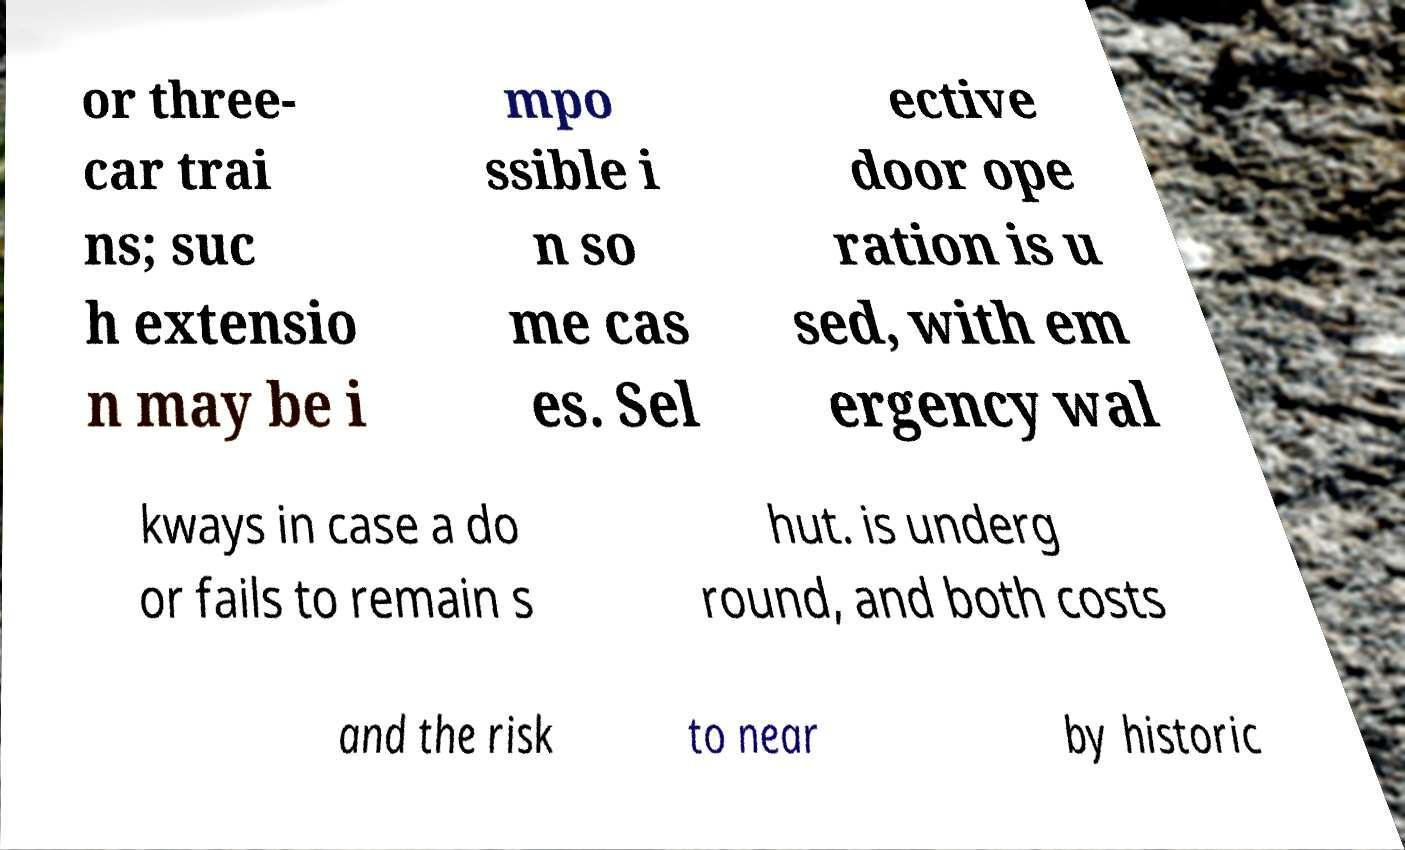Can you read and provide the text displayed in the image?This photo seems to have some interesting text. Can you extract and type it out for me? or three- car trai ns; suc h extensio n may be i mpo ssible i n so me cas es. Sel ective door ope ration is u sed, with em ergency wal kways in case a do or fails to remain s hut. is underg round, and both costs and the risk to near by historic 